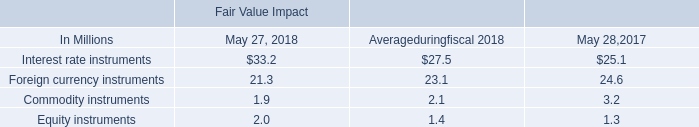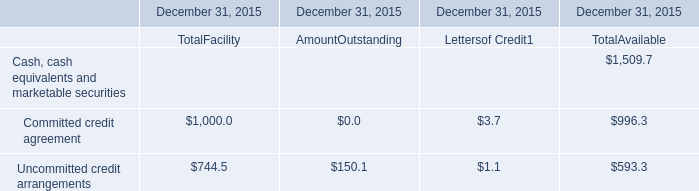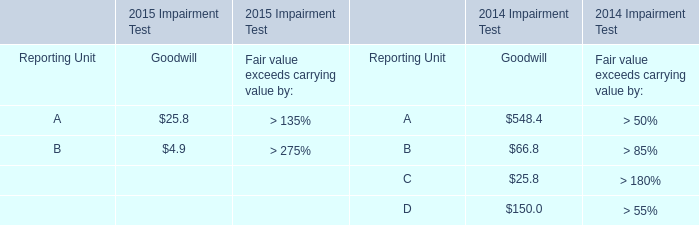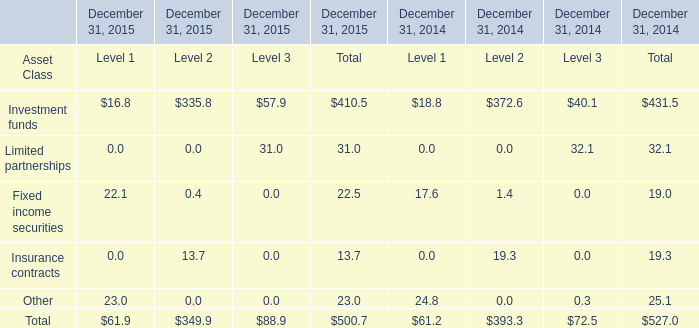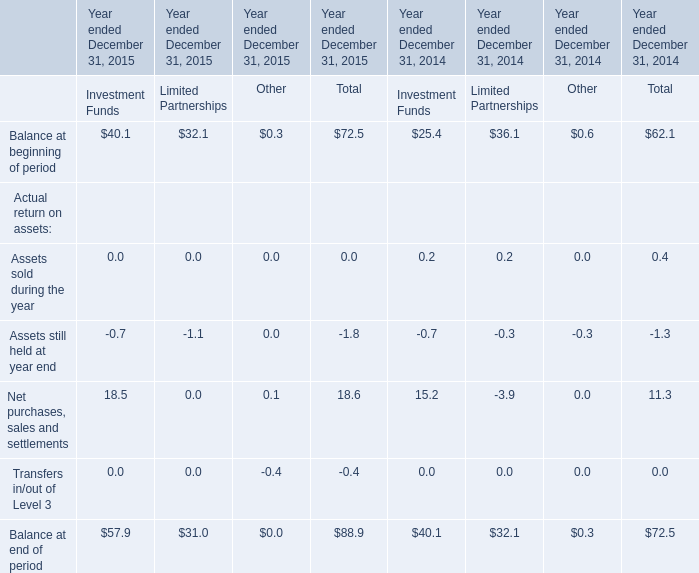What is the sum of Other in the range of 0 and 2 in 2015? 
Computations: (0.3 + 0.1)
Answer: 0.4. 